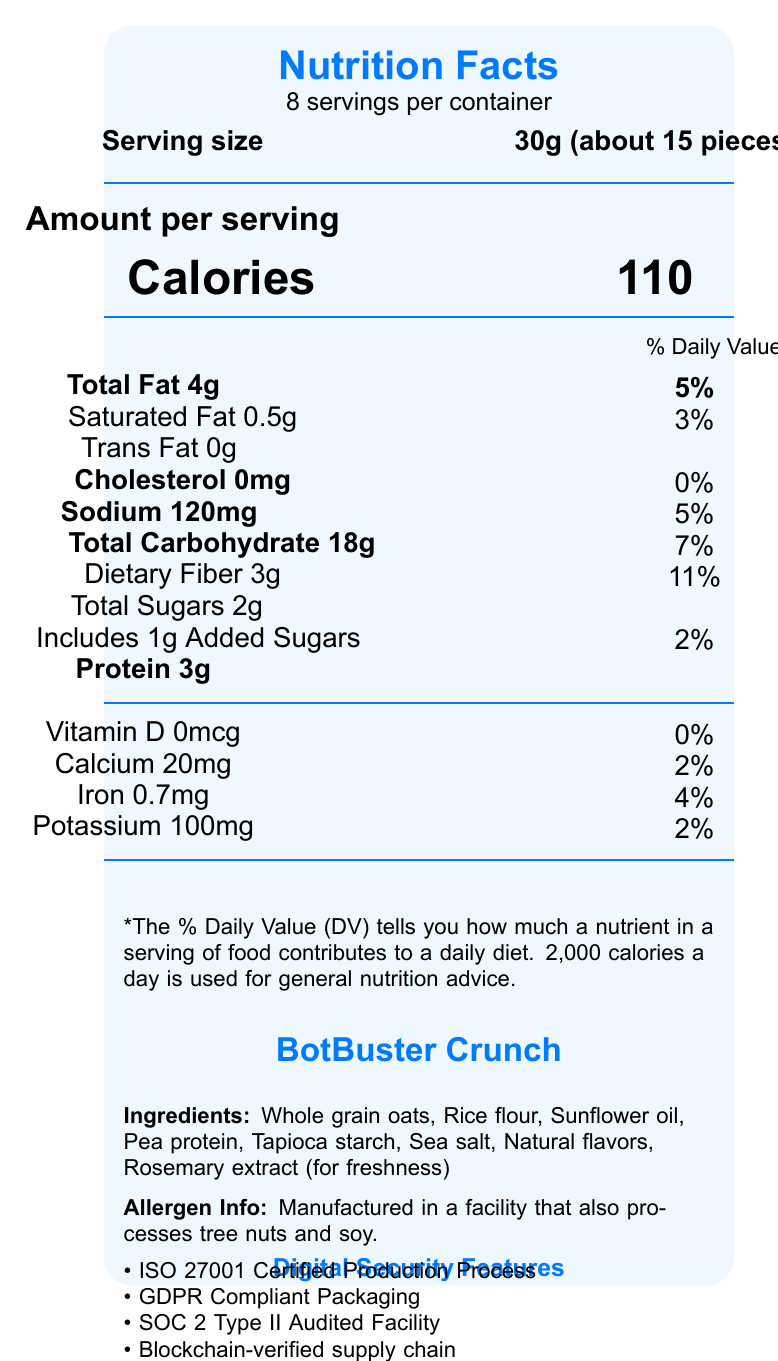what is the serving size? The serving size is listed at the top of the nutrition facts section as "30g (about 15 pieces)".
Answer: 30g (about 15 pieces) how many servings per container are there? This information is located just below the "Nutrition Facts" heading: "8 servings per container".
Answer: 8 how much total fat is in one serving? The total fat content per serving is listed as "Total Fat 4g".
Answer: 4g what is the amount of dietary fiber per serving? The dietary fiber content per serving is marked as "Dietary Fiber 3g".
Answer: 3g what is one of the main ingredients? The ingredients list starts with "Whole grain oats", indicating it is a main ingredient.
Answer: Whole grain oats how many calories are there per serving? The calories per serving are listed in a large font as "Calories 110".
Answer: 110 what percentage of the daily value for sodium does one serving provide? The sodium daily value percentage is listed as "5%" next to "Sodium 120mg".
Answer: 5% how many grams of protein are in one serving? The protein content per serving is noted as "Protein 3g".
Answer: 3g how much added sugar does one serving include? The added sugars content per serving is noted as "Includes 1g Added Sugars".
Answer: 1g does the product contain any trans fat? The document states "Trans Fat 0g", indicating no trans fat is present.
Answer: No which digital security feature is not mentioned? A. ISO 27001 B. SSL Encryption C. GDPR Compliance D. SOC 2 Type II SSL Encryption is not listed among the digital security features. The others are covered.
Answer: B. SSL Encryption how many calories would you consume if you ate two servings? A. 110 calories B. 220 calories C. 330 calories D. 440 calories Since each serving has 110 calories, consuming two servings would total 220 calories (110 + 110).
Answer: B. 220 calories does the product offer blockchain-verified supply chain? The "tech features" section in the document mentions "Blockchain-verified supply chain".
Answer: Yes how much vitamin D is provided per serving? The vitamin D content per serving is listed as "Vitamin D 0mcg".
Answer: 0mcg is the product free from artificial sweeteners? The marketing claims state "0g artificial sweeteners or malicious code".
Answer: Yes what are the health benefits of the product? The nutrition facts highlight low total sugars, adequate dietary fiber, and essential nutrients like calcium and potassium.
Answer: The product offers low sugar content, dietary fiber, and essential vitamins and minerals. what allergen information is provided? This information is provided at the bottom of the document under "Allergen Info".
Answer: The product is manufactured in a facility that also processes tree nuts and soy. estimate the total amount of protein in the entire container. There are 8 servings per container, each with 3g of protein: 8 servings * 3g = 24g.
Answer: 24g describe the main idea of the document. It provides a comprehensive overview of the product's nutritional content, health benefits, and unique digital and security features aimed at tech-savvy consumers.
Answer: The document details the nutrition facts, ingredients, allergen info, marketing claims, and tech features of BotBuster Crunch, a digital-security-focused, low-sugar snack. what is the manufacturing location for BotBuster Crunch? The document does not provide any information about the manufacturing location of the product.
Answer: Cannot be determined 